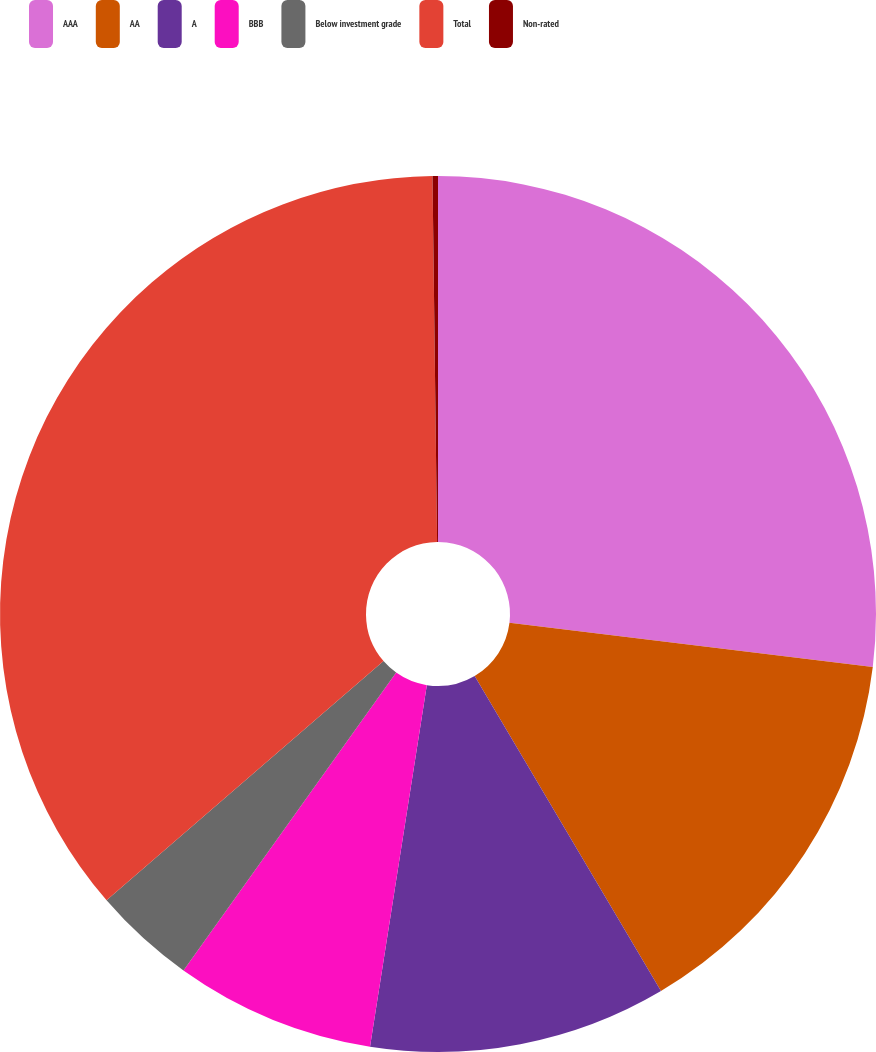Convert chart. <chart><loc_0><loc_0><loc_500><loc_500><pie_chart><fcel>AAA<fcel>AA<fcel>A<fcel>BBB<fcel>Below investment grade<fcel>Total<fcel>Non-rated<nl><fcel>26.93%<fcel>14.57%<fcel>10.98%<fcel>7.39%<fcel>3.79%<fcel>36.14%<fcel>0.2%<nl></chart> 